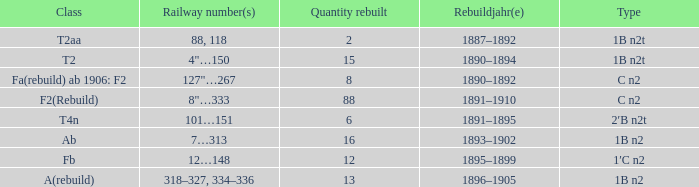What is the type if quantity rebuilt is more than 2 and the railway number is 4"…150? 1B n2t. 